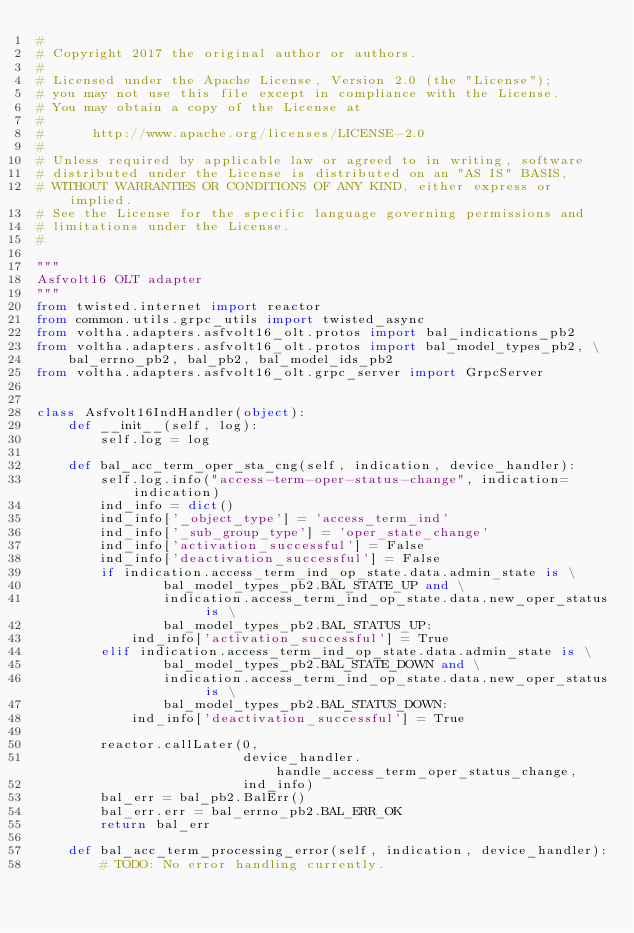Convert code to text. <code><loc_0><loc_0><loc_500><loc_500><_Python_>#
# Copyright 2017 the original author or authors.
#
# Licensed under the Apache License, Version 2.0 (the "License");
# you may not use this file except in compliance with the License.
# You may obtain a copy of the License at
#
#      http://www.apache.org/licenses/LICENSE-2.0
#
# Unless required by applicable law or agreed to in writing, software
# distributed under the License is distributed on an "AS IS" BASIS,
# WITHOUT WARRANTIES OR CONDITIONS OF ANY KIND, either express or implied.
# See the License for the specific language governing permissions and
# limitations under the License.
#

"""
Asfvolt16 OLT adapter
"""
from twisted.internet import reactor
from common.utils.grpc_utils import twisted_async
from voltha.adapters.asfvolt16_olt.protos import bal_indications_pb2
from voltha.adapters.asfvolt16_olt.protos import bal_model_types_pb2, \
    bal_errno_pb2, bal_pb2, bal_model_ids_pb2
from voltha.adapters.asfvolt16_olt.grpc_server import GrpcServer


class Asfvolt16IndHandler(object):
    def __init__(self, log):
        self.log = log

    def bal_acc_term_oper_sta_cng(self, indication, device_handler):
        self.log.info("access-term-oper-status-change", indication=indication)
        ind_info = dict()
        ind_info['_object_type'] = 'access_term_ind'
        ind_info['_sub_group_type'] = 'oper_state_change'
        ind_info['activation_successful'] = False
        ind_info['deactivation_successful'] = False
        if indication.access_term_ind_op_state.data.admin_state is \
                bal_model_types_pb2.BAL_STATE_UP and \
                indication.access_term_ind_op_state.data.new_oper_status is \
                bal_model_types_pb2.BAL_STATUS_UP:
            ind_info['activation_successful'] = True
        elif indication.access_term_ind_op_state.data.admin_state is \
                bal_model_types_pb2.BAL_STATE_DOWN and \
                indication.access_term_ind_op_state.data.new_oper_status is \
                bal_model_types_pb2.BAL_STATUS_DOWN:
            ind_info['deactivation_successful'] = True

        reactor.callLater(0,
                          device_handler.handle_access_term_oper_status_change,
                          ind_info)
        bal_err = bal_pb2.BalErr()
        bal_err.err = bal_errno_pb2.BAL_ERR_OK
        return bal_err

    def bal_acc_term_processing_error(self, indication, device_handler):
        # TODO: No error handling currently.</code> 